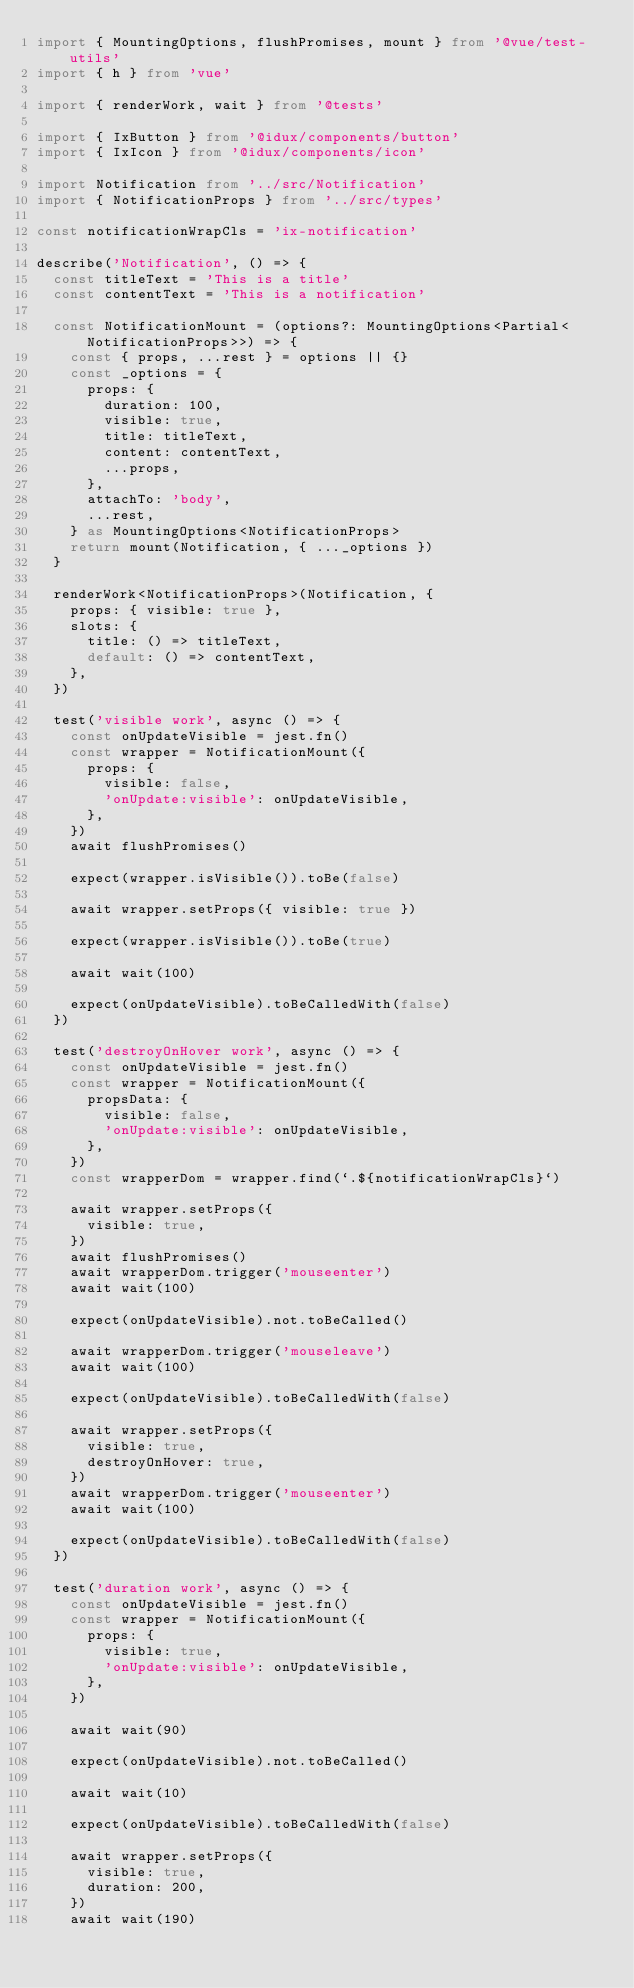Convert code to text. <code><loc_0><loc_0><loc_500><loc_500><_TypeScript_>import { MountingOptions, flushPromises, mount } from '@vue/test-utils'
import { h } from 'vue'

import { renderWork, wait } from '@tests'

import { IxButton } from '@idux/components/button'
import { IxIcon } from '@idux/components/icon'

import Notification from '../src/Notification'
import { NotificationProps } from '../src/types'

const notificationWrapCls = 'ix-notification'

describe('Notification', () => {
  const titleText = 'This is a title'
  const contentText = 'This is a notification'

  const NotificationMount = (options?: MountingOptions<Partial<NotificationProps>>) => {
    const { props, ...rest } = options || {}
    const _options = {
      props: {
        duration: 100,
        visible: true,
        title: titleText,
        content: contentText,
        ...props,
      },
      attachTo: 'body',
      ...rest,
    } as MountingOptions<NotificationProps>
    return mount(Notification, { ..._options })
  }

  renderWork<NotificationProps>(Notification, {
    props: { visible: true },
    slots: {
      title: () => titleText,
      default: () => contentText,
    },
  })

  test('visible work', async () => {
    const onUpdateVisible = jest.fn()
    const wrapper = NotificationMount({
      props: {
        visible: false,
        'onUpdate:visible': onUpdateVisible,
      },
    })
    await flushPromises()

    expect(wrapper.isVisible()).toBe(false)

    await wrapper.setProps({ visible: true })

    expect(wrapper.isVisible()).toBe(true)

    await wait(100)

    expect(onUpdateVisible).toBeCalledWith(false)
  })

  test('destroyOnHover work', async () => {
    const onUpdateVisible = jest.fn()
    const wrapper = NotificationMount({
      propsData: {
        visible: false,
        'onUpdate:visible': onUpdateVisible,
      },
    })
    const wrapperDom = wrapper.find(`.${notificationWrapCls}`)

    await wrapper.setProps({
      visible: true,
    })
    await flushPromises()
    await wrapperDom.trigger('mouseenter')
    await wait(100)

    expect(onUpdateVisible).not.toBeCalled()

    await wrapperDom.trigger('mouseleave')
    await wait(100)

    expect(onUpdateVisible).toBeCalledWith(false)

    await wrapper.setProps({
      visible: true,
      destroyOnHover: true,
    })
    await wrapperDom.trigger('mouseenter')
    await wait(100)

    expect(onUpdateVisible).toBeCalledWith(false)
  })

  test('duration work', async () => {
    const onUpdateVisible = jest.fn()
    const wrapper = NotificationMount({
      props: {
        visible: true,
        'onUpdate:visible': onUpdateVisible,
      },
    })

    await wait(90)

    expect(onUpdateVisible).not.toBeCalled()

    await wait(10)

    expect(onUpdateVisible).toBeCalledWith(false)

    await wrapper.setProps({
      visible: true,
      duration: 200,
    })
    await wait(190)
</code> 